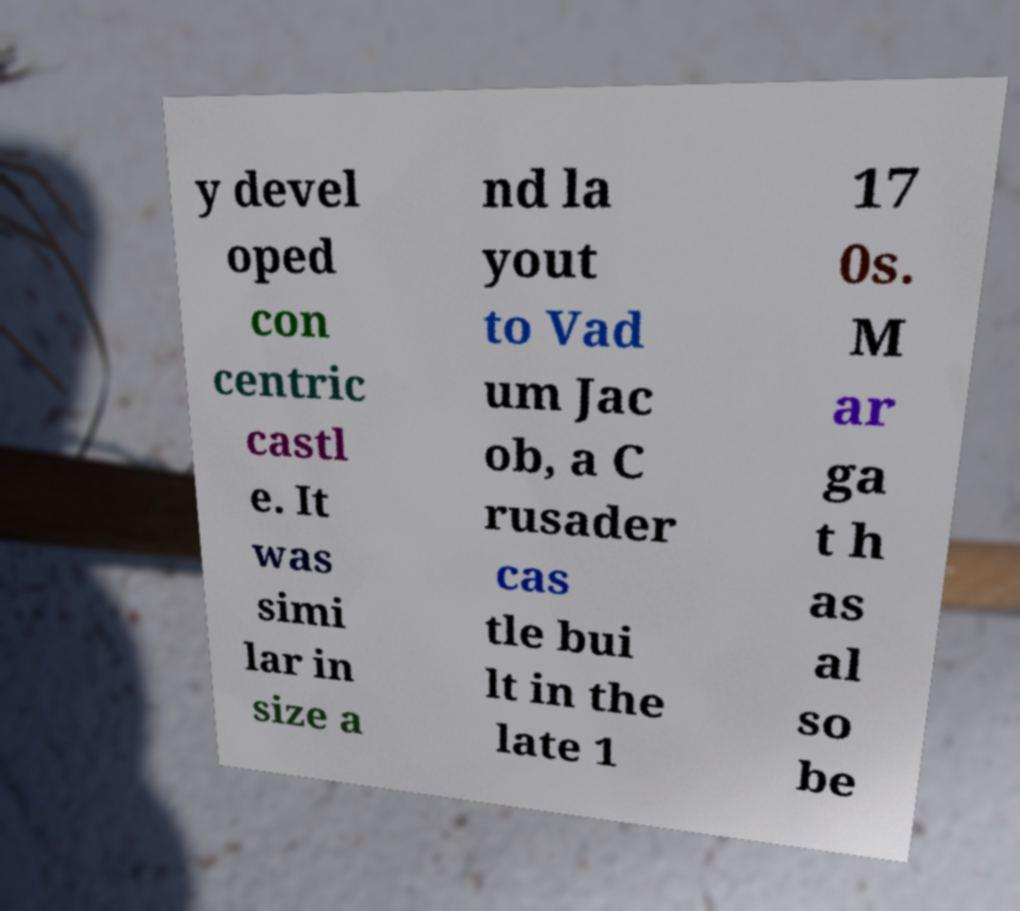For documentation purposes, I need the text within this image transcribed. Could you provide that? y devel oped con centric castl e. It was simi lar in size a nd la yout to Vad um Jac ob, a C rusader cas tle bui lt in the late 1 17 0s. M ar ga t h as al so be 